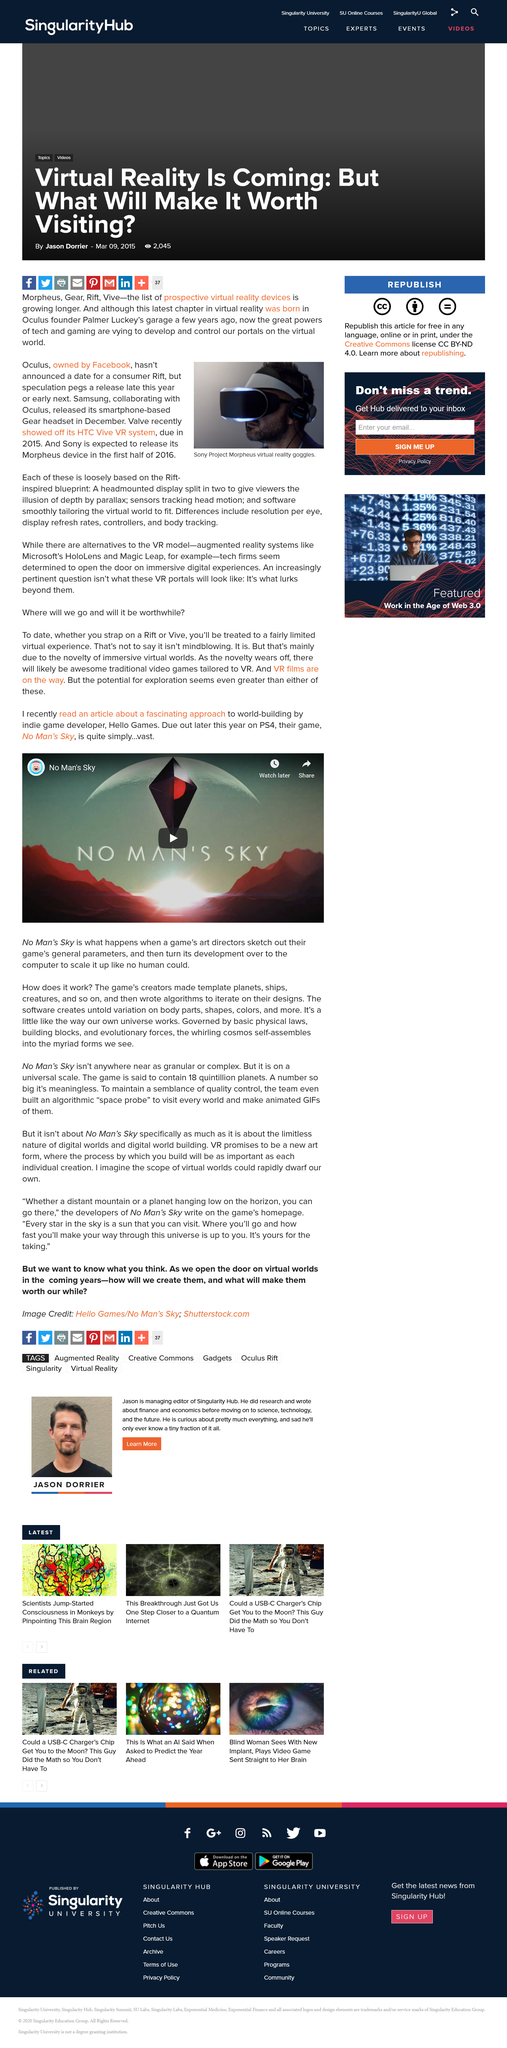Specify some key components in this picture. The game creators created templates for planets, ships, and creatures. Sony is expected to release its Morpheus device in the first half of 2016. It is a fact that the game parameters were sketched out by the art directors, not the directors. Oculus, which is owned by Facebook, is a well-known company in the field of virtual reality technology. The name of the game is No Man's Sky. 